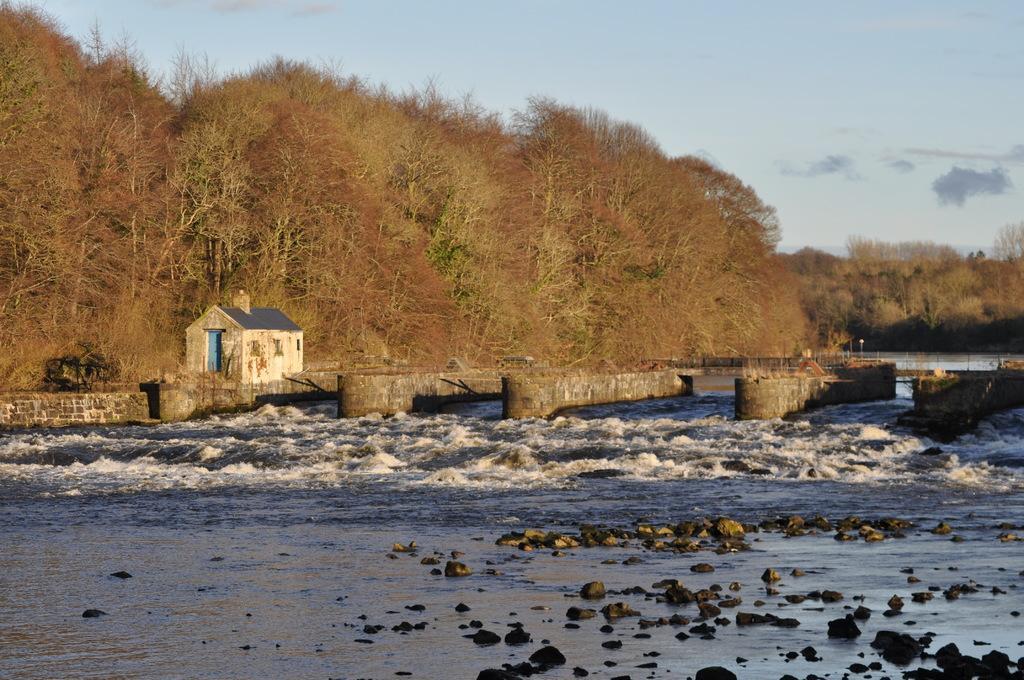Please provide a concise description of this image. In the center of the image we can see bridge, house, trees, water are there. At the top of the image clouds are present in the sky. At the bottom of the image some stones are there. 